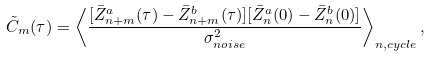<formula> <loc_0><loc_0><loc_500><loc_500>\tilde { C } _ { m } ( \tau ) = \left < \frac { [ \bar { Z } _ { n + m } ^ { a } ( \tau ) - \bar { Z } _ { n + m } ^ { b } ( \tau ) ] [ \bar { Z } _ { n } ^ { a } ( 0 ) - \bar { Z } _ { n } ^ { b } ( 0 ) ] } { \sigma _ { n o i s e } ^ { 2 } } \right > _ { n , c y c l e } ,</formula> 